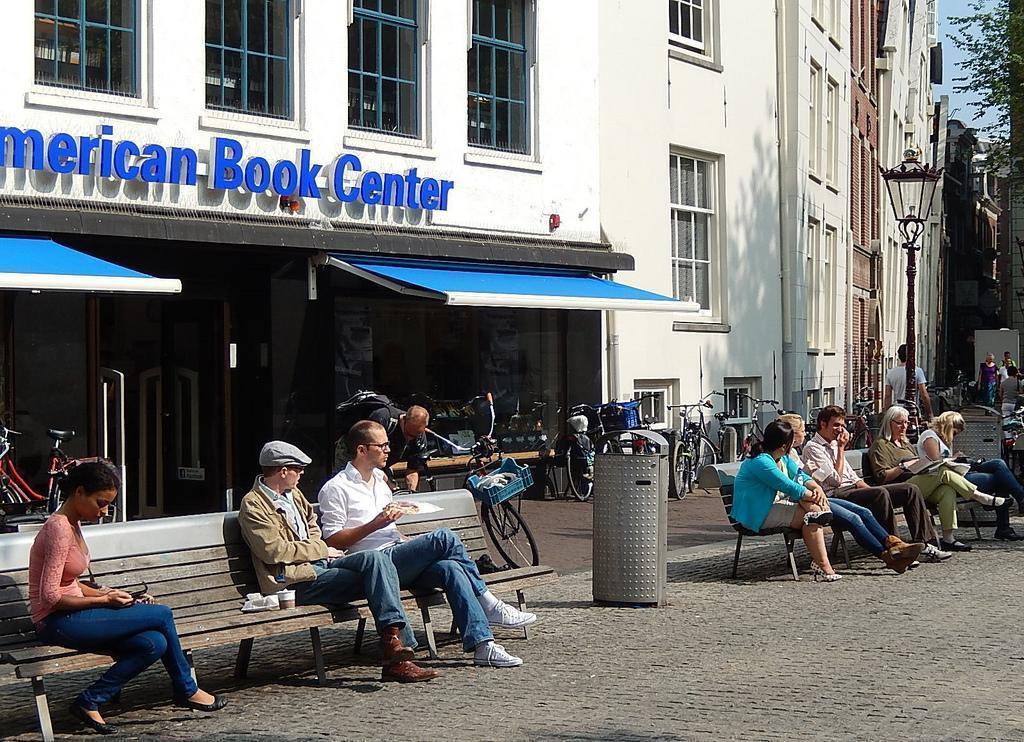How many people is wearing cap?
Give a very brief answer. 1. 